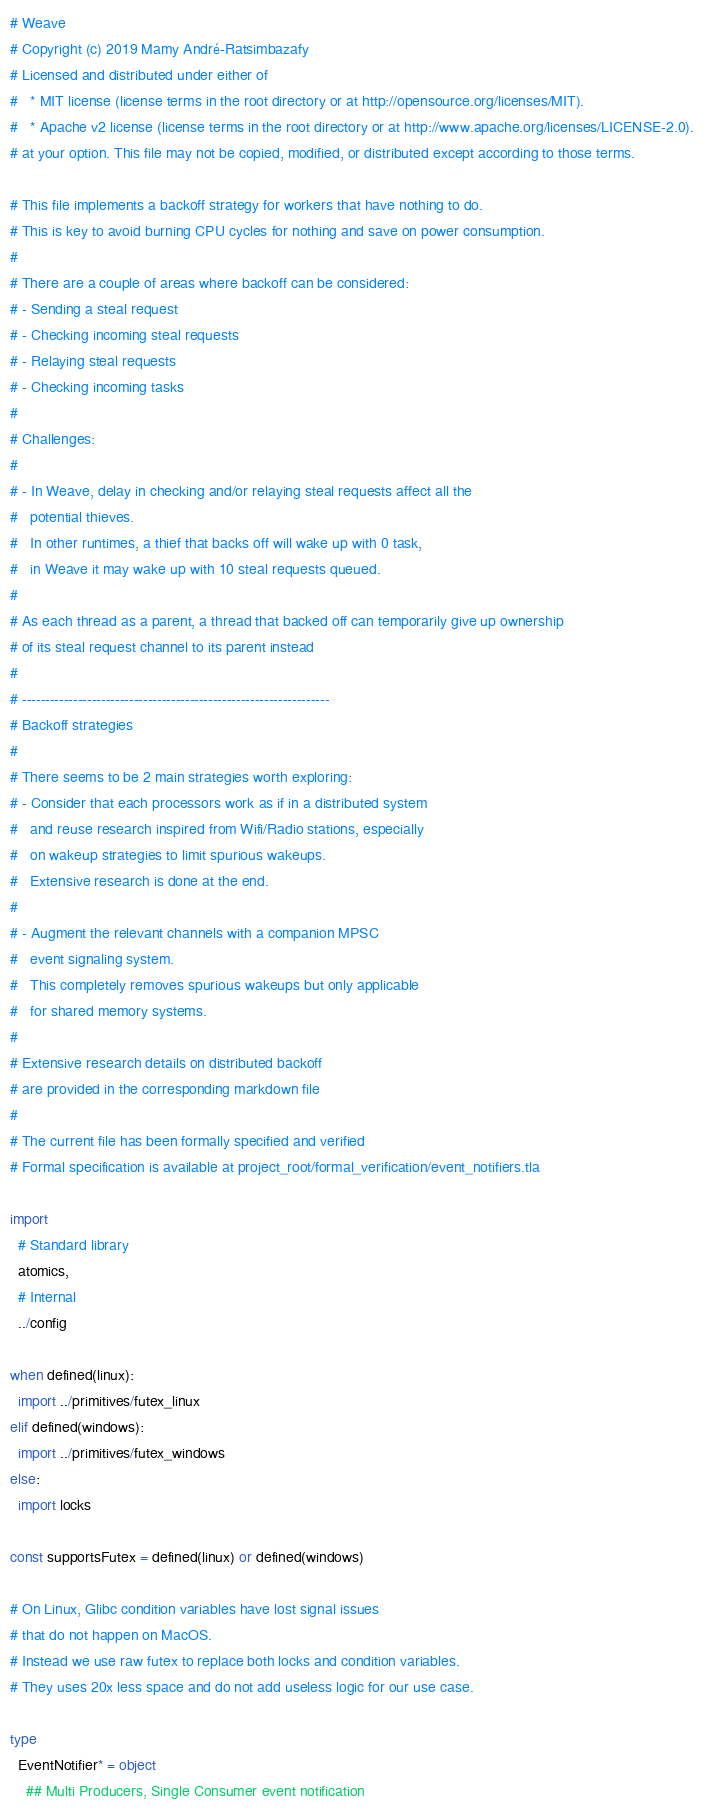Convert code to text. <code><loc_0><loc_0><loc_500><loc_500><_Nim_># Weave
# Copyright (c) 2019 Mamy André-Ratsimbazafy
# Licensed and distributed under either of
#   * MIT license (license terms in the root directory or at http://opensource.org/licenses/MIT).
#   * Apache v2 license (license terms in the root directory or at http://www.apache.org/licenses/LICENSE-2.0).
# at your option. This file may not be copied, modified, or distributed except according to those terms.

# This file implements a backoff strategy for workers that have nothing to do.
# This is key to avoid burning CPU cycles for nothing and save on power consumption.
#
# There are a couple of areas where backoff can be considered:
# - Sending a steal request
# - Checking incoming steal requests
# - Relaying steal requests
# - Checking incoming tasks
#
# Challenges:
#
# - In Weave, delay in checking and/or relaying steal requests affect all the
#   potential thieves.
#   In other runtimes, a thief that backs off will wake up with 0 task,
#   in Weave it may wake up with 10 steal requests queued.
#
# As each thread as a parent, a thread that backed off can temporarily give up ownership
# of its steal request channel to its parent instead
#
# ------------------------------------------------------------------
# Backoff strategies
#
# There seems to be 2 main strategies worth exploring:
# - Consider that each processors work as if in a distributed system
#   and reuse research inspired from Wifi/Radio stations, especially
#   on wakeup strategies to limit spurious wakeups.
#   Extensive research is done at the end.
#
# - Augment the relevant channels with a companion MPSC
#   event signaling system.
#   This completely removes spurious wakeups but only applicable
#   for shared memory systems.
#
# Extensive research details on distributed backoff
# are provided in the corresponding markdown file
#
# The current file has been formally specified and verified
# Formal specification is available at project_root/formal_verification/event_notifiers.tla

import
  # Standard library
  atomics,
  # Internal
  ../config

when defined(linux):
  import ../primitives/futex_linux
elif defined(windows):
  import ../primitives/futex_windows
else:
  import locks

const supportsFutex = defined(linux) or defined(windows)

# On Linux, Glibc condition variables have lost signal issues
# that do not happen on MacOS.
# Instead we use raw futex to replace both locks and condition variables.
# They uses 20x less space and do not add useless logic for our use case.

type
  EventNotifier* = object
    ## Multi Producers, Single Consumer event notification</code> 